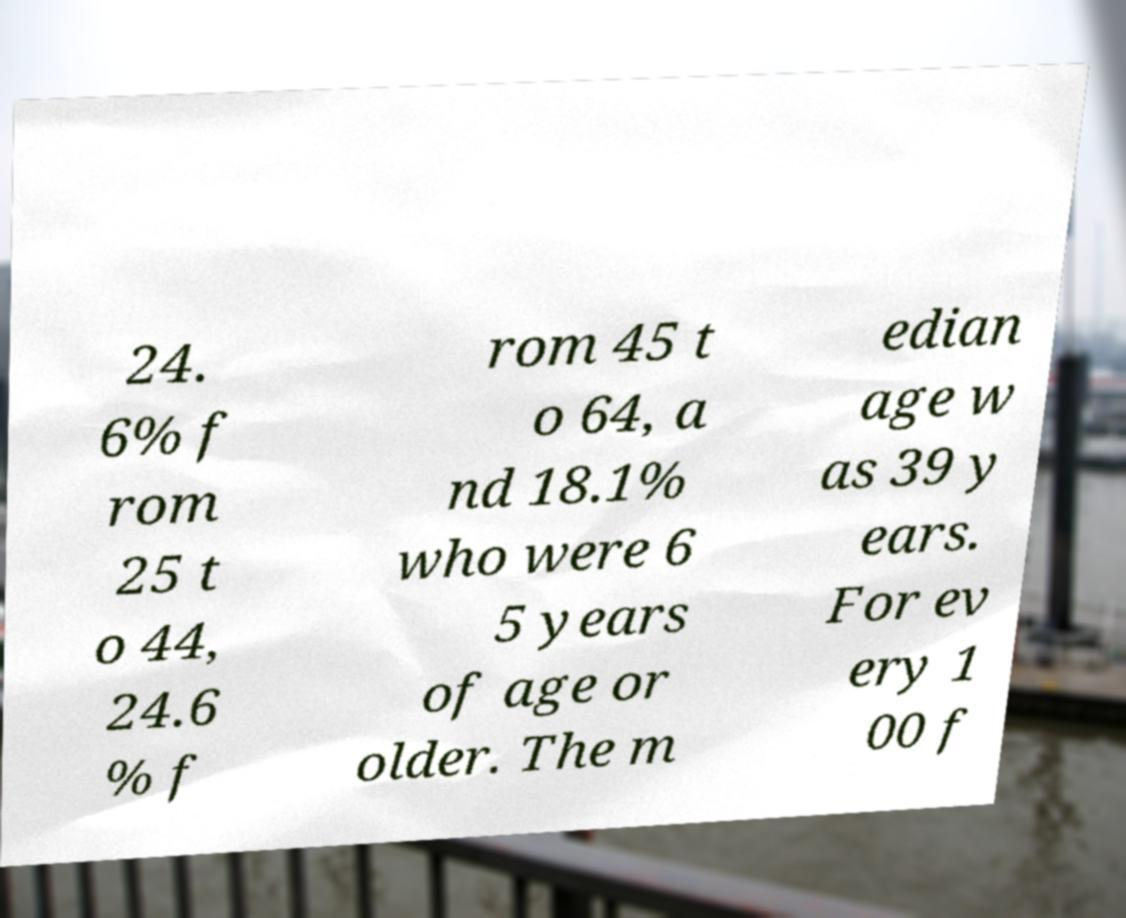What messages or text are displayed in this image? I need them in a readable, typed format. 24. 6% f rom 25 t o 44, 24.6 % f rom 45 t o 64, a nd 18.1% who were 6 5 years of age or older. The m edian age w as 39 y ears. For ev ery 1 00 f 